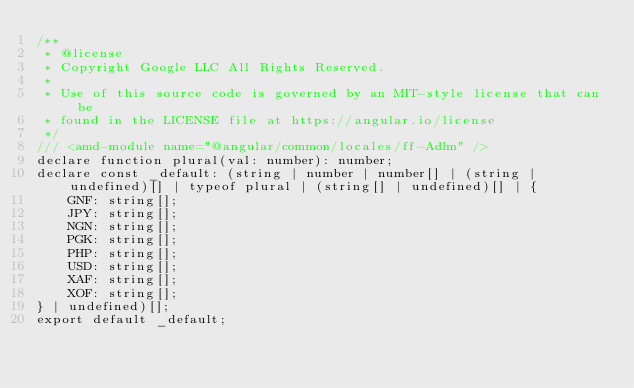Convert code to text. <code><loc_0><loc_0><loc_500><loc_500><_TypeScript_>/**
 * @license
 * Copyright Google LLC All Rights Reserved.
 *
 * Use of this source code is governed by an MIT-style license that can be
 * found in the LICENSE file at https://angular.io/license
 */
/// <amd-module name="@angular/common/locales/ff-Adlm" />
declare function plural(val: number): number;
declare const _default: (string | number | number[] | (string | undefined)[] | typeof plural | (string[] | undefined)[] | {
    GNF: string[];
    JPY: string[];
    NGN: string[];
    PGK: string[];
    PHP: string[];
    USD: string[];
    XAF: string[];
    XOF: string[];
} | undefined)[];
export default _default;
</code> 